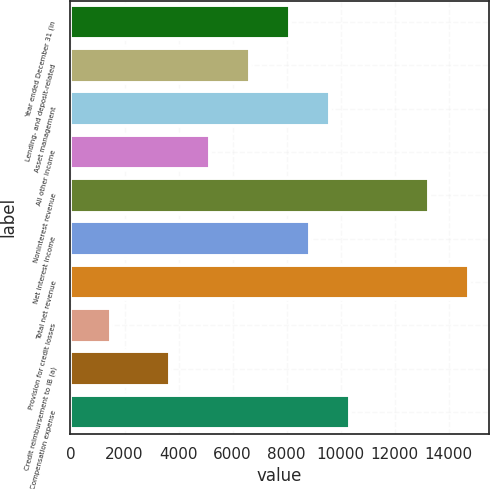<chart> <loc_0><loc_0><loc_500><loc_500><bar_chart><fcel>Year ended December 31 (in<fcel>Lending- and deposit-related<fcel>Asset management<fcel>All other income<fcel>Noninterest revenue<fcel>Net interest income<fcel>Total net revenue<fcel>Provision for credit losses<fcel>Credit reimbursement to IB (a)<fcel>Compensation expense<nl><fcel>8117.4<fcel>6644.6<fcel>9590.2<fcel>5171.8<fcel>13272.2<fcel>8853.8<fcel>14745<fcel>1489.8<fcel>3699<fcel>10326.6<nl></chart> 